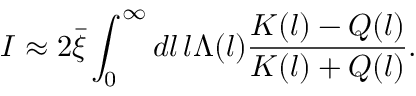Convert formula to latex. <formula><loc_0><loc_0><loc_500><loc_500>I \approx 2 \bar { \xi } \int _ { 0 } ^ { \infty } d l \, l \Lambda ( l ) { \frac { K ( l ) - Q ( l ) } { K ( l ) + Q ( l ) } } .</formula> 